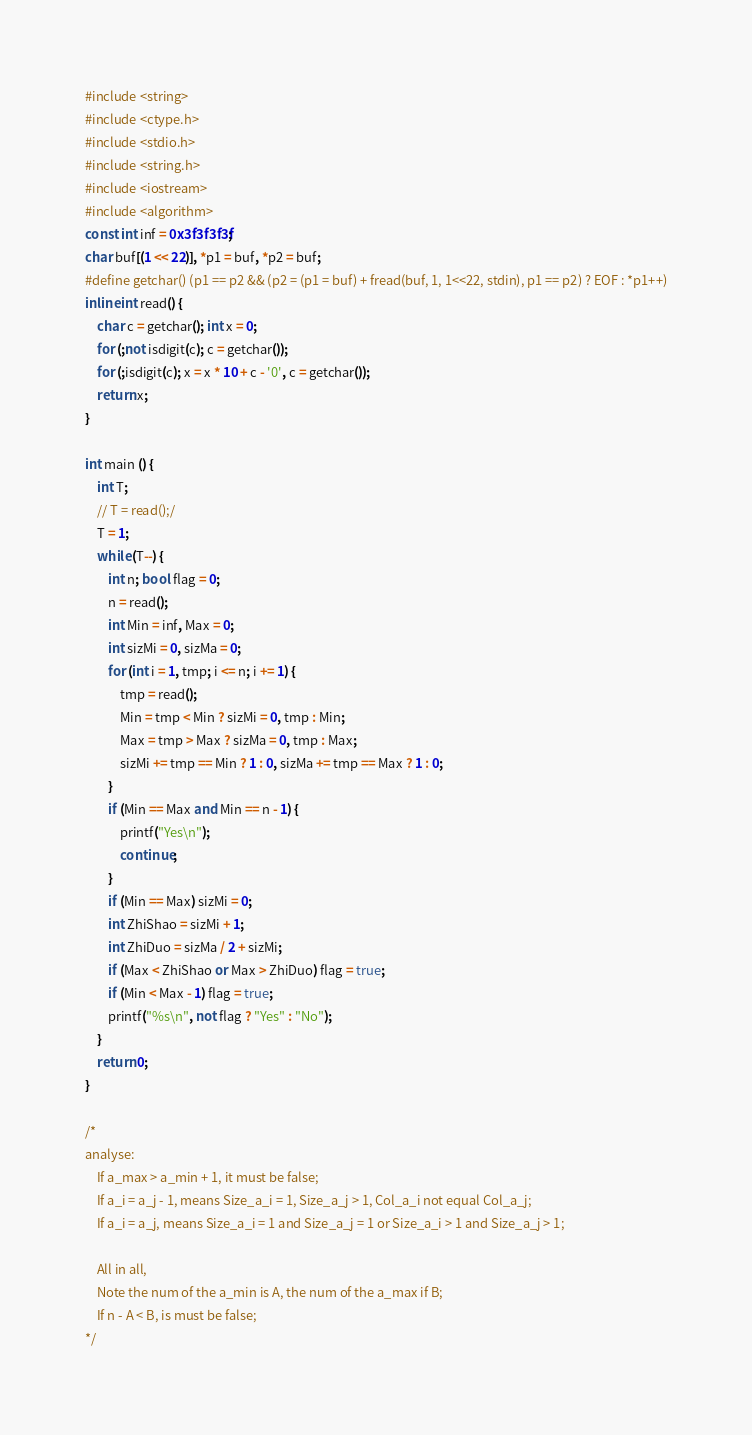Convert code to text. <code><loc_0><loc_0><loc_500><loc_500><_C++_>#include <string>
#include <ctype.h>
#include <stdio.h>
#include <string.h>
#include <iostream>
#include <algorithm>
const int inf = 0x3f3f3f3f;
char buf[(1 << 22)], *p1 = buf, *p2 = buf;
#define getchar() (p1 == p2 && (p2 = (p1 = buf) + fread(buf, 1, 1<<22, stdin), p1 == p2) ? EOF : *p1++)
inline int read() {
    char c = getchar(); int x = 0;
    for (;not isdigit(c); c = getchar());
    for (;isdigit(c); x = x * 10 + c - '0', c = getchar());
    return x;
}

int main () {
    int T;
    // T = read();/
    T = 1;
    while (T--) {
        int n; bool flag = 0;
        n = read();
        int Min = inf, Max = 0;
        int sizMi = 0, sizMa = 0;
        for (int i = 1, tmp; i <= n; i += 1) {
            tmp = read();
            Min = tmp < Min ? sizMi = 0, tmp : Min;
            Max = tmp > Max ? sizMa = 0, tmp : Max;
            sizMi += tmp == Min ? 1 : 0, sizMa += tmp == Max ? 1 : 0;
        }
        if (Min == Max and Min == n - 1) {
        	printf("Yes\n");
        	continue;
        }
        if (Min == Max) sizMi = 0;
        int ZhiShao = sizMi + 1;
        int ZhiDuo = sizMa / 2 + sizMi;
        if (Max < ZhiShao or Max > ZhiDuo) flag = true;
        if (Min < Max - 1) flag = true;
        printf("%s\n", not flag ? "Yes" : "No");
    }
    return 0;
}

/*
analyse:
    If a_max > a_min + 1, it must be false;
    If a_i = a_j - 1, means Size_a_i = 1, Size_a_j > 1, Col_a_i not equal Col_a_j;
    If a_i = a_j, means Size_a_i = 1 and Size_a_j = 1 or Size_a_i > 1 and Size_a_j > 1;
    
    All in all, 
    Note the num of the a_min is A, the num of the a_max if B;
    If n - A < B, is must be false;
*/
</code> 